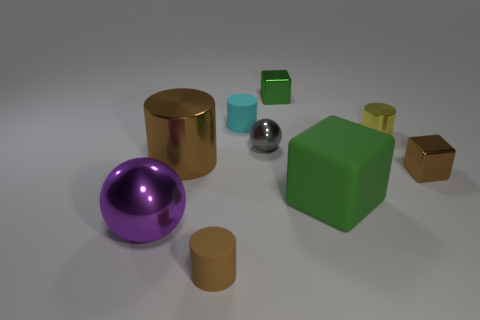Can you tell me which objects in the image might be considered as potentially being able to float in water? Given the objects in the image, potential candidates for floating are the green cube and the green square due to their shapes and volumes which, if hollow or made of a light, buoyant material, could allow them to float on water. 